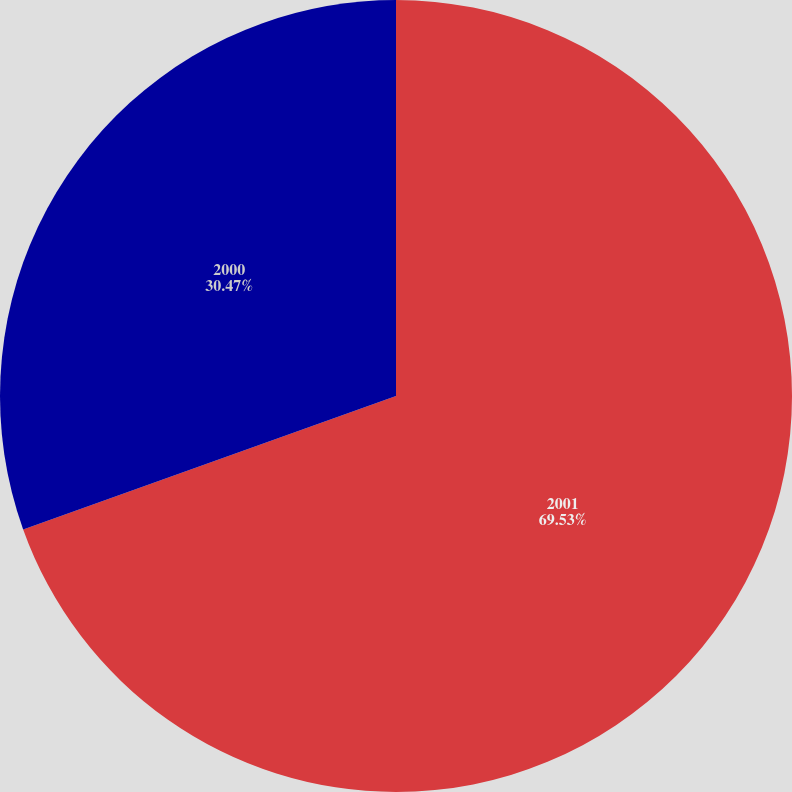Convert chart to OTSL. <chart><loc_0><loc_0><loc_500><loc_500><pie_chart><fcel>2001<fcel>2000<nl><fcel>69.53%<fcel>30.47%<nl></chart> 